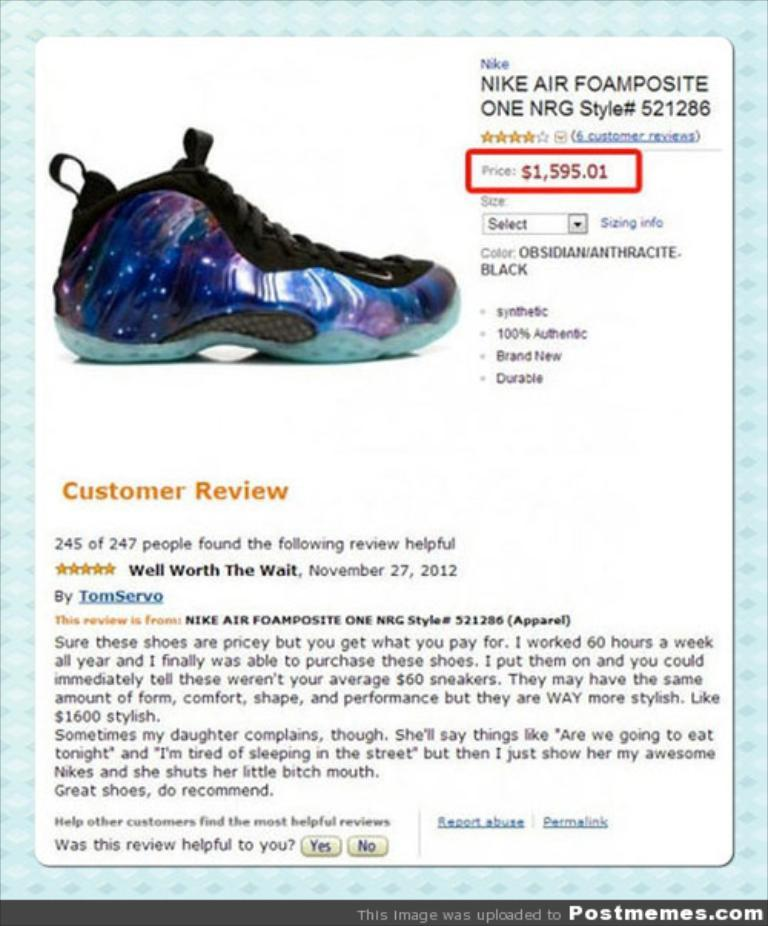What is featured in the image? There is a poster in the image. What can be found on the poster? The poster contains text and an image of a shoe. What type of quilt is draped over the table in the image? There is no quilt or table present in the image; it only features a poster with text and an image of a shoe. 